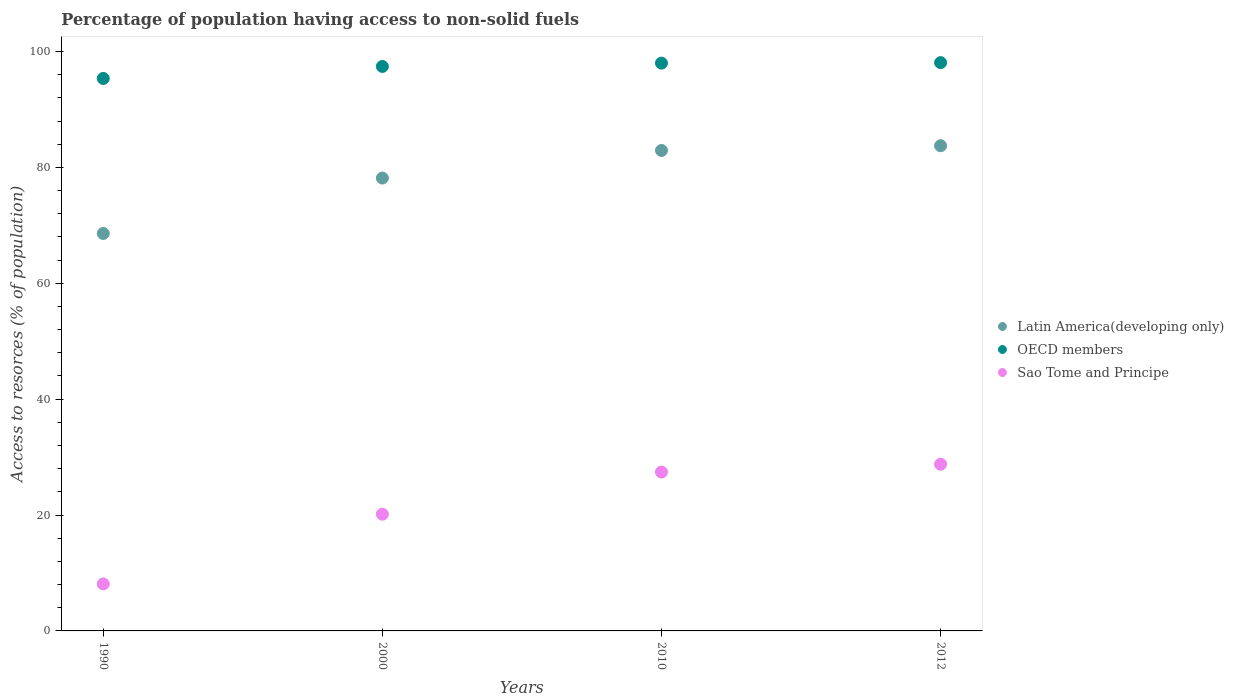How many different coloured dotlines are there?
Offer a very short reply. 3. Is the number of dotlines equal to the number of legend labels?
Give a very brief answer. Yes. What is the percentage of population having access to non-solid fuels in OECD members in 2010?
Offer a very short reply. 97.99. Across all years, what is the maximum percentage of population having access to non-solid fuels in Sao Tome and Principe?
Your answer should be compact. 28.77. Across all years, what is the minimum percentage of population having access to non-solid fuels in Latin America(developing only)?
Give a very brief answer. 68.59. In which year was the percentage of population having access to non-solid fuels in OECD members maximum?
Ensure brevity in your answer.  2012. What is the total percentage of population having access to non-solid fuels in Latin America(developing only) in the graph?
Keep it short and to the point. 313.41. What is the difference between the percentage of population having access to non-solid fuels in Latin America(developing only) in 2000 and that in 2010?
Offer a terse response. -4.76. What is the difference between the percentage of population having access to non-solid fuels in OECD members in 1990 and the percentage of population having access to non-solid fuels in Sao Tome and Principe in 2012?
Offer a terse response. 66.58. What is the average percentage of population having access to non-solid fuels in Sao Tome and Principe per year?
Your response must be concise. 21.11. In the year 2000, what is the difference between the percentage of population having access to non-solid fuels in OECD members and percentage of population having access to non-solid fuels in Sao Tome and Principe?
Make the answer very short. 77.27. What is the ratio of the percentage of population having access to non-solid fuels in Latin America(developing only) in 1990 to that in 2010?
Provide a short and direct response. 0.83. What is the difference between the highest and the second highest percentage of population having access to non-solid fuels in OECD members?
Your answer should be compact. 0.08. What is the difference between the highest and the lowest percentage of population having access to non-solid fuels in Sao Tome and Principe?
Give a very brief answer. 20.65. Does the percentage of population having access to non-solid fuels in Sao Tome and Principe monotonically increase over the years?
Make the answer very short. Yes. Is the percentage of population having access to non-solid fuels in Sao Tome and Principe strictly greater than the percentage of population having access to non-solid fuels in Latin America(developing only) over the years?
Ensure brevity in your answer.  No. How many dotlines are there?
Ensure brevity in your answer.  3. What is the difference between two consecutive major ticks on the Y-axis?
Your answer should be very brief. 20. Where does the legend appear in the graph?
Ensure brevity in your answer.  Center right. What is the title of the graph?
Your answer should be very brief. Percentage of population having access to non-solid fuels. What is the label or title of the X-axis?
Offer a very short reply. Years. What is the label or title of the Y-axis?
Make the answer very short. Access to resorces (% of population). What is the Access to resorces (% of population) in Latin America(developing only) in 1990?
Keep it short and to the point. 68.59. What is the Access to resorces (% of population) in OECD members in 1990?
Give a very brief answer. 95.34. What is the Access to resorces (% of population) in Sao Tome and Principe in 1990?
Your answer should be very brief. 8.11. What is the Access to resorces (% of population) in Latin America(developing only) in 2000?
Provide a short and direct response. 78.16. What is the Access to resorces (% of population) of OECD members in 2000?
Give a very brief answer. 97.42. What is the Access to resorces (% of population) in Sao Tome and Principe in 2000?
Your answer should be very brief. 20.14. What is the Access to resorces (% of population) in Latin America(developing only) in 2010?
Ensure brevity in your answer.  82.92. What is the Access to resorces (% of population) in OECD members in 2010?
Provide a succinct answer. 97.99. What is the Access to resorces (% of population) in Sao Tome and Principe in 2010?
Your answer should be compact. 27.42. What is the Access to resorces (% of population) of Latin America(developing only) in 2012?
Your answer should be compact. 83.73. What is the Access to resorces (% of population) of OECD members in 2012?
Your response must be concise. 98.07. What is the Access to resorces (% of population) in Sao Tome and Principe in 2012?
Provide a succinct answer. 28.77. Across all years, what is the maximum Access to resorces (% of population) in Latin America(developing only)?
Provide a short and direct response. 83.73. Across all years, what is the maximum Access to resorces (% of population) in OECD members?
Keep it short and to the point. 98.07. Across all years, what is the maximum Access to resorces (% of population) of Sao Tome and Principe?
Keep it short and to the point. 28.77. Across all years, what is the minimum Access to resorces (% of population) of Latin America(developing only)?
Provide a short and direct response. 68.59. Across all years, what is the minimum Access to resorces (% of population) in OECD members?
Your answer should be very brief. 95.34. Across all years, what is the minimum Access to resorces (% of population) of Sao Tome and Principe?
Offer a terse response. 8.11. What is the total Access to resorces (% of population) of Latin America(developing only) in the graph?
Your answer should be very brief. 313.41. What is the total Access to resorces (% of population) of OECD members in the graph?
Your answer should be very brief. 388.83. What is the total Access to resorces (% of population) in Sao Tome and Principe in the graph?
Give a very brief answer. 84.44. What is the difference between the Access to resorces (% of population) of Latin America(developing only) in 1990 and that in 2000?
Your answer should be compact. -9.56. What is the difference between the Access to resorces (% of population) of OECD members in 1990 and that in 2000?
Offer a very short reply. -2.07. What is the difference between the Access to resorces (% of population) in Sao Tome and Principe in 1990 and that in 2000?
Your answer should be very brief. -12.03. What is the difference between the Access to resorces (% of population) in Latin America(developing only) in 1990 and that in 2010?
Offer a terse response. -14.32. What is the difference between the Access to resorces (% of population) of OECD members in 1990 and that in 2010?
Provide a succinct answer. -2.65. What is the difference between the Access to resorces (% of population) in Sao Tome and Principe in 1990 and that in 2010?
Offer a very short reply. -19.31. What is the difference between the Access to resorces (% of population) of Latin America(developing only) in 1990 and that in 2012?
Make the answer very short. -15.14. What is the difference between the Access to resorces (% of population) of OECD members in 1990 and that in 2012?
Make the answer very short. -2.73. What is the difference between the Access to resorces (% of population) in Sao Tome and Principe in 1990 and that in 2012?
Keep it short and to the point. -20.65. What is the difference between the Access to resorces (% of population) of Latin America(developing only) in 2000 and that in 2010?
Give a very brief answer. -4.76. What is the difference between the Access to resorces (% of population) of OECD members in 2000 and that in 2010?
Your response must be concise. -0.57. What is the difference between the Access to resorces (% of population) of Sao Tome and Principe in 2000 and that in 2010?
Keep it short and to the point. -7.27. What is the difference between the Access to resorces (% of population) in Latin America(developing only) in 2000 and that in 2012?
Provide a short and direct response. -5.58. What is the difference between the Access to resorces (% of population) in OECD members in 2000 and that in 2012?
Ensure brevity in your answer.  -0.66. What is the difference between the Access to resorces (% of population) of Sao Tome and Principe in 2000 and that in 2012?
Keep it short and to the point. -8.62. What is the difference between the Access to resorces (% of population) in Latin America(developing only) in 2010 and that in 2012?
Provide a short and direct response. -0.82. What is the difference between the Access to resorces (% of population) in OECD members in 2010 and that in 2012?
Keep it short and to the point. -0.08. What is the difference between the Access to resorces (% of population) of Sao Tome and Principe in 2010 and that in 2012?
Ensure brevity in your answer.  -1.35. What is the difference between the Access to resorces (% of population) of Latin America(developing only) in 1990 and the Access to resorces (% of population) of OECD members in 2000?
Your answer should be very brief. -28.82. What is the difference between the Access to resorces (% of population) in Latin America(developing only) in 1990 and the Access to resorces (% of population) in Sao Tome and Principe in 2000?
Offer a terse response. 48.45. What is the difference between the Access to resorces (% of population) of OECD members in 1990 and the Access to resorces (% of population) of Sao Tome and Principe in 2000?
Ensure brevity in your answer.  75.2. What is the difference between the Access to resorces (% of population) of Latin America(developing only) in 1990 and the Access to resorces (% of population) of OECD members in 2010?
Provide a short and direct response. -29.4. What is the difference between the Access to resorces (% of population) in Latin America(developing only) in 1990 and the Access to resorces (% of population) in Sao Tome and Principe in 2010?
Provide a succinct answer. 41.18. What is the difference between the Access to resorces (% of population) in OECD members in 1990 and the Access to resorces (% of population) in Sao Tome and Principe in 2010?
Your response must be concise. 67.93. What is the difference between the Access to resorces (% of population) of Latin America(developing only) in 1990 and the Access to resorces (% of population) of OECD members in 2012?
Ensure brevity in your answer.  -29.48. What is the difference between the Access to resorces (% of population) of Latin America(developing only) in 1990 and the Access to resorces (% of population) of Sao Tome and Principe in 2012?
Give a very brief answer. 39.83. What is the difference between the Access to resorces (% of population) of OECD members in 1990 and the Access to resorces (% of population) of Sao Tome and Principe in 2012?
Offer a very short reply. 66.58. What is the difference between the Access to resorces (% of population) in Latin America(developing only) in 2000 and the Access to resorces (% of population) in OECD members in 2010?
Your answer should be very brief. -19.83. What is the difference between the Access to resorces (% of population) in Latin America(developing only) in 2000 and the Access to resorces (% of population) in Sao Tome and Principe in 2010?
Make the answer very short. 50.74. What is the difference between the Access to resorces (% of population) in OECD members in 2000 and the Access to resorces (% of population) in Sao Tome and Principe in 2010?
Your response must be concise. 70. What is the difference between the Access to resorces (% of population) in Latin America(developing only) in 2000 and the Access to resorces (% of population) in OECD members in 2012?
Your answer should be very brief. -19.91. What is the difference between the Access to resorces (% of population) in Latin America(developing only) in 2000 and the Access to resorces (% of population) in Sao Tome and Principe in 2012?
Offer a terse response. 49.39. What is the difference between the Access to resorces (% of population) of OECD members in 2000 and the Access to resorces (% of population) of Sao Tome and Principe in 2012?
Keep it short and to the point. 68.65. What is the difference between the Access to resorces (% of population) of Latin America(developing only) in 2010 and the Access to resorces (% of population) of OECD members in 2012?
Ensure brevity in your answer.  -15.16. What is the difference between the Access to resorces (% of population) in Latin America(developing only) in 2010 and the Access to resorces (% of population) in Sao Tome and Principe in 2012?
Your answer should be very brief. 54.15. What is the difference between the Access to resorces (% of population) of OECD members in 2010 and the Access to resorces (% of population) of Sao Tome and Principe in 2012?
Your answer should be compact. 69.23. What is the average Access to resorces (% of population) in Latin America(developing only) per year?
Provide a short and direct response. 78.35. What is the average Access to resorces (% of population) in OECD members per year?
Offer a terse response. 97.21. What is the average Access to resorces (% of population) in Sao Tome and Principe per year?
Make the answer very short. 21.11. In the year 1990, what is the difference between the Access to resorces (% of population) of Latin America(developing only) and Access to resorces (% of population) of OECD members?
Offer a terse response. -26.75. In the year 1990, what is the difference between the Access to resorces (% of population) of Latin America(developing only) and Access to resorces (% of population) of Sao Tome and Principe?
Your answer should be very brief. 60.48. In the year 1990, what is the difference between the Access to resorces (% of population) of OECD members and Access to resorces (% of population) of Sao Tome and Principe?
Offer a very short reply. 87.23. In the year 2000, what is the difference between the Access to resorces (% of population) in Latin America(developing only) and Access to resorces (% of population) in OECD members?
Your response must be concise. -19.26. In the year 2000, what is the difference between the Access to resorces (% of population) in Latin America(developing only) and Access to resorces (% of population) in Sao Tome and Principe?
Provide a short and direct response. 58.01. In the year 2000, what is the difference between the Access to resorces (% of population) in OECD members and Access to resorces (% of population) in Sao Tome and Principe?
Your response must be concise. 77.27. In the year 2010, what is the difference between the Access to resorces (% of population) of Latin America(developing only) and Access to resorces (% of population) of OECD members?
Your answer should be very brief. -15.07. In the year 2010, what is the difference between the Access to resorces (% of population) of Latin America(developing only) and Access to resorces (% of population) of Sao Tome and Principe?
Provide a short and direct response. 55.5. In the year 2010, what is the difference between the Access to resorces (% of population) in OECD members and Access to resorces (% of population) in Sao Tome and Principe?
Give a very brief answer. 70.57. In the year 2012, what is the difference between the Access to resorces (% of population) of Latin America(developing only) and Access to resorces (% of population) of OECD members?
Offer a very short reply. -14.34. In the year 2012, what is the difference between the Access to resorces (% of population) in Latin America(developing only) and Access to resorces (% of population) in Sao Tome and Principe?
Make the answer very short. 54.97. In the year 2012, what is the difference between the Access to resorces (% of population) of OECD members and Access to resorces (% of population) of Sao Tome and Principe?
Ensure brevity in your answer.  69.31. What is the ratio of the Access to resorces (% of population) in Latin America(developing only) in 1990 to that in 2000?
Your answer should be compact. 0.88. What is the ratio of the Access to resorces (% of population) in OECD members in 1990 to that in 2000?
Keep it short and to the point. 0.98. What is the ratio of the Access to resorces (% of population) of Sao Tome and Principe in 1990 to that in 2000?
Your answer should be very brief. 0.4. What is the ratio of the Access to resorces (% of population) in Latin America(developing only) in 1990 to that in 2010?
Your answer should be very brief. 0.83. What is the ratio of the Access to resorces (% of population) of Sao Tome and Principe in 1990 to that in 2010?
Your response must be concise. 0.3. What is the ratio of the Access to resorces (% of population) in Latin America(developing only) in 1990 to that in 2012?
Your response must be concise. 0.82. What is the ratio of the Access to resorces (% of population) of OECD members in 1990 to that in 2012?
Make the answer very short. 0.97. What is the ratio of the Access to resorces (% of population) of Sao Tome and Principe in 1990 to that in 2012?
Your response must be concise. 0.28. What is the ratio of the Access to resorces (% of population) of Latin America(developing only) in 2000 to that in 2010?
Your answer should be very brief. 0.94. What is the ratio of the Access to resorces (% of population) of OECD members in 2000 to that in 2010?
Ensure brevity in your answer.  0.99. What is the ratio of the Access to resorces (% of population) of Sao Tome and Principe in 2000 to that in 2010?
Provide a short and direct response. 0.73. What is the ratio of the Access to resorces (% of population) of Latin America(developing only) in 2000 to that in 2012?
Your answer should be compact. 0.93. What is the ratio of the Access to resorces (% of population) of Sao Tome and Principe in 2000 to that in 2012?
Provide a short and direct response. 0.7. What is the ratio of the Access to resorces (% of population) in Latin America(developing only) in 2010 to that in 2012?
Offer a terse response. 0.99. What is the ratio of the Access to resorces (% of population) of OECD members in 2010 to that in 2012?
Your response must be concise. 1. What is the ratio of the Access to resorces (% of population) in Sao Tome and Principe in 2010 to that in 2012?
Provide a short and direct response. 0.95. What is the difference between the highest and the second highest Access to resorces (% of population) in Latin America(developing only)?
Provide a succinct answer. 0.82. What is the difference between the highest and the second highest Access to resorces (% of population) in OECD members?
Your response must be concise. 0.08. What is the difference between the highest and the second highest Access to resorces (% of population) in Sao Tome and Principe?
Offer a terse response. 1.35. What is the difference between the highest and the lowest Access to resorces (% of population) in Latin America(developing only)?
Your answer should be compact. 15.14. What is the difference between the highest and the lowest Access to resorces (% of population) of OECD members?
Provide a short and direct response. 2.73. What is the difference between the highest and the lowest Access to resorces (% of population) of Sao Tome and Principe?
Give a very brief answer. 20.65. 